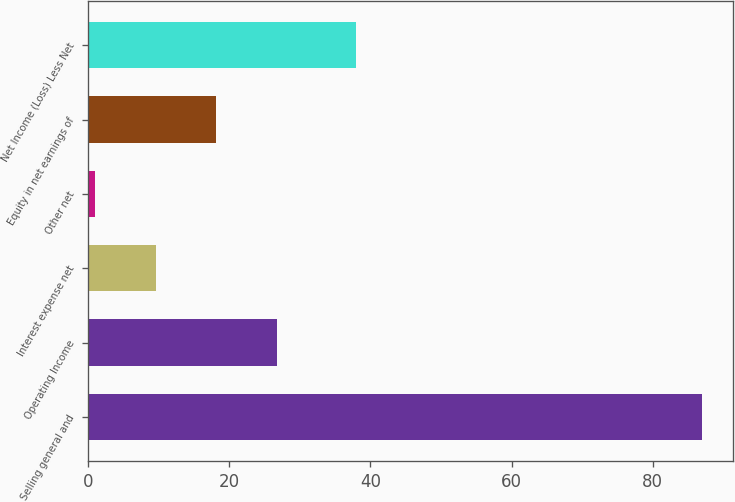Convert chart to OTSL. <chart><loc_0><loc_0><loc_500><loc_500><bar_chart><fcel>Selling general and<fcel>Operating Income<fcel>Interest expense net<fcel>Other net<fcel>Equity in net earnings of<fcel>Net Income (Loss) Less Net<nl><fcel>87<fcel>26.8<fcel>9.6<fcel>1<fcel>18.2<fcel>38<nl></chart> 